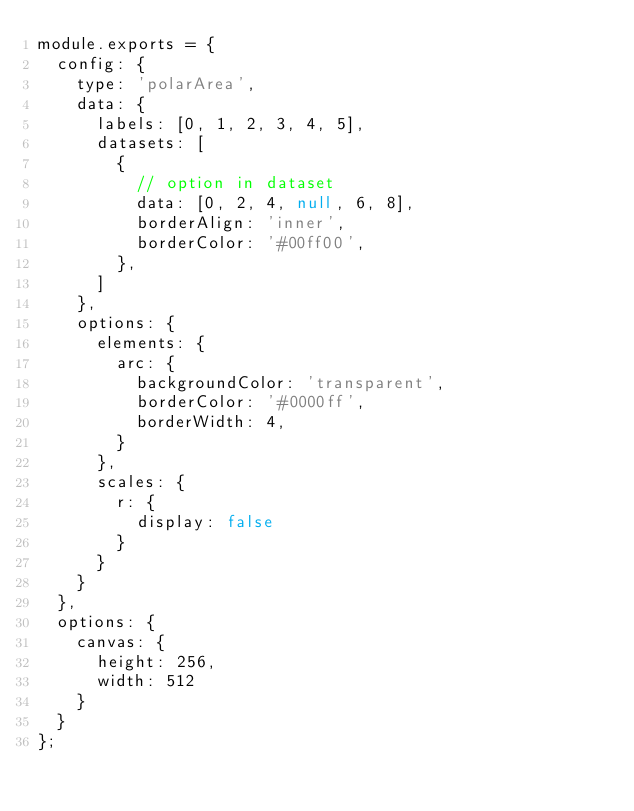<code> <loc_0><loc_0><loc_500><loc_500><_JavaScript_>module.exports = {
	config: {
		type: 'polarArea',
		data: {
			labels: [0, 1, 2, 3, 4, 5],
			datasets: [
				{
					// option in dataset
					data: [0, 2, 4, null, 6, 8],
					borderAlign: 'inner',
					borderColor: '#00ff00',
				},
			]
		},
		options: {
			elements: {
				arc: {
					backgroundColor: 'transparent',
					borderColor: '#0000ff',
					borderWidth: 4,
				}
			},
			scales: {
				r: {
					display: false
				}
			}
		}
	},
	options: {
		canvas: {
			height: 256,
			width: 512
		}
	}
};
</code> 